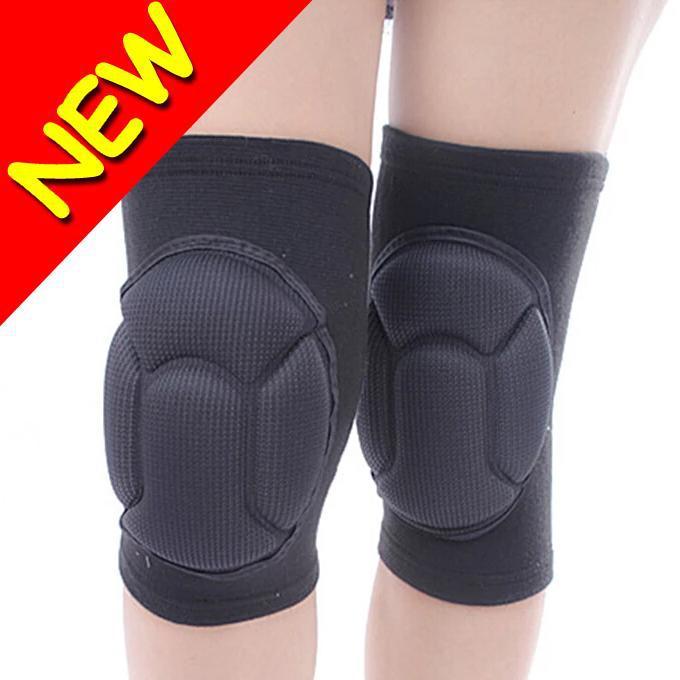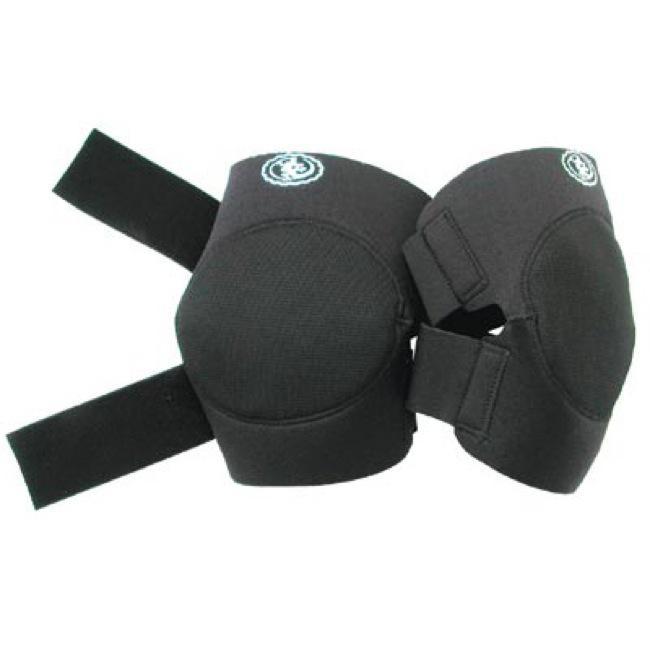The first image is the image on the left, the second image is the image on the right. Assess this claim about the two images: "An image includes a pair of human legs wearing black knee-pads.". Correct or not? Answer yes or no. Yes. The first image is the image on the left, the second image is the image on the right. Considering the images on both sides, is "The left image shows at least one pair of knee caps that are being worn on a person's legs" valid? Answer yes or no. Yes. 